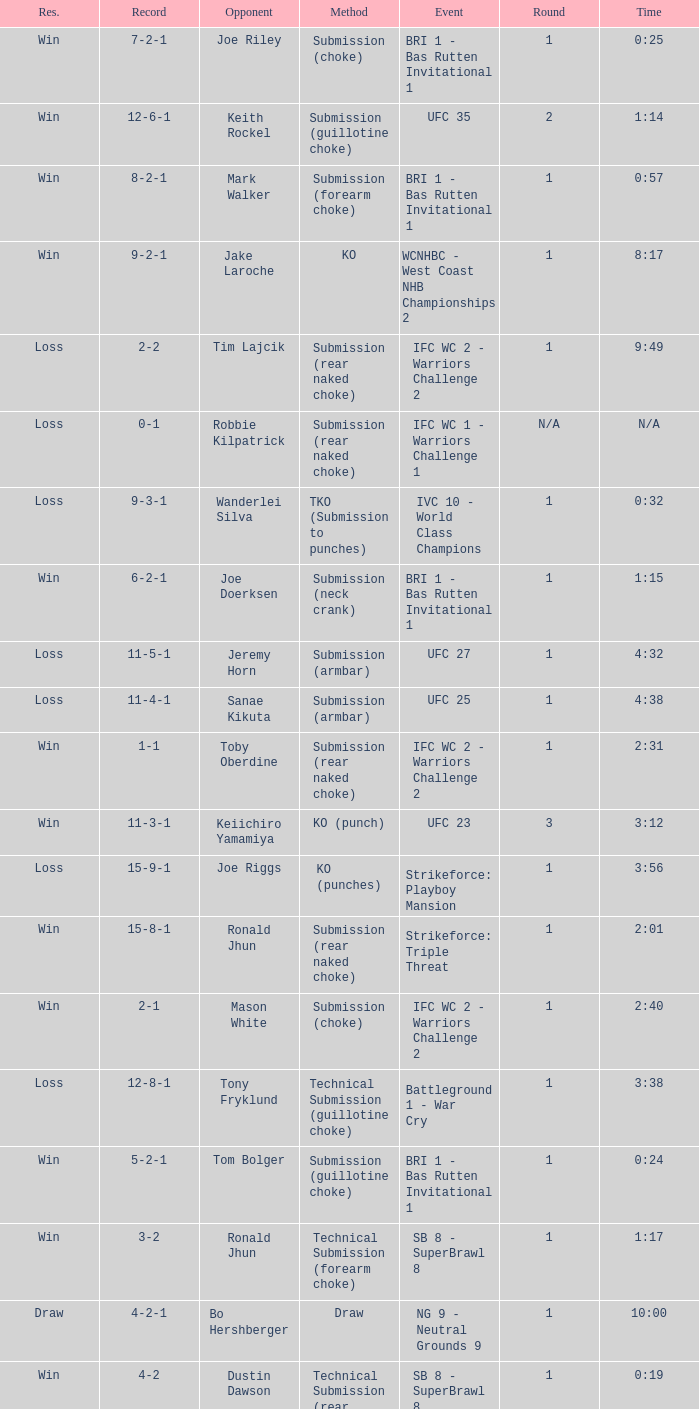What was the record when the method of resolution was KO? 9-2-1. 